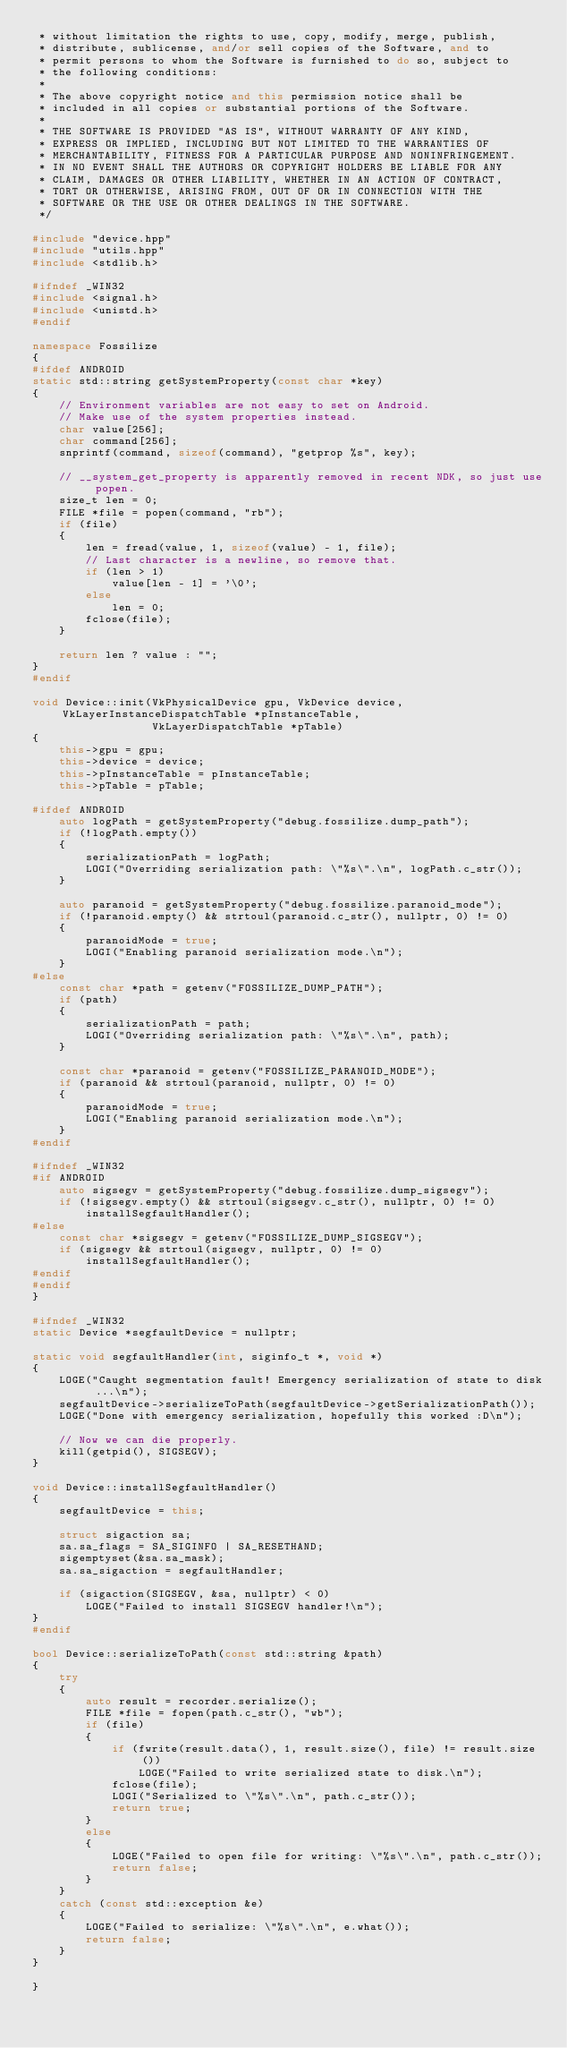Convert code to text. <code><loc_0><loc_0><loc_500><loc_500><_C++_> * without limitation the rights to use, copy, modify, merge, publish,
 * distribute, sublicense, and/or sell copies of the Software, and to
 * permit persons to whom the Software is furnished to do so, subject to
 * the following conditions:
 *
 * The above copyright notice and this permission notice shall be
 * included in all copies or substantial portions of the Software.
 *
 * THE SOFTWARE IS PROVIDED "AS IS", WITHOUT WARRANTY OF ANY KIND,
 * EXPRESS OR IMPLIED, INCLUDING BUT NOT LIMITED TO THE WARRANTIES OF
 * MERCHANTABILITY, FITNESS FOR A PARTICULAR PURPOSE AND NONINFRINGEMENT.
 * IN NO EVENT SHALL THE AUTHORS OR COPYRIGHT HOLDERS BE LIABLE FOR ANY
 * CLAIM, DAMAGES OR OTHER LIABILITY, WHETHER IN AN ACTION OF CONTRACT,
 * TORT OR OTHERWISE, ARISING FROM, OUT OF OR IN CONNECTION WITH THE
 * SOFTWARE OR THE USE OR OTHER DEALINGS IN THE SOFTWARE.
 */

#include "device.hpp"
#include "utils.hpp"
#include <stdlib.h>

#ifndef _WIN32
#include <signal.h>
#include <unistd.h>
#endif

namespace Fossilize
{
#ifdef ANDROID
static std::string getSystemProperty(const char *key)
{
	// Environment variables are not easy to set on Android.
	// Make use of the system properties instead.
	char value[256];
	char command[256];
	snprintf(command, sizeof(command), "getprop %s", key);

	// __system_get_property is apparently removed in recent NDK, so just use popen.
	size_t len = 0;
	FILE *file = popen(command, "rb");
	if (file)
	{
		len = fread(value, 1, sizeof(value) - 1, file);
		// Last character is a newline, so remove that.
		if (len > 1)
			value[len - 1] = '\0';
		else
			len = 0;
		fclose(file);
	}

	return len ? value : "";
}
#endif

void Device::init(VkPhysicalDevice gpu, VkDevice device, VkLayerInstanceDispatchTable *pInstanceTable,
                  VkLayerDispatchTable *pTable)
{
	this->gpu = gpu;
	this->device = device;
	this->pInstanceTable = pInstanceTable;
	this->pTable = pTable;

#ifdef ANDROID
	auto logPath = getSystemProperty("debug.fossilize.dump_path");
	if (!logPath.empty())
	{
		serializationPath = logPath;
		LOGI("Overriding serialization path: \"%s\".\n", logPath.c_str());
	}

	auto paranoid = getSystemProperty("debug.fossilize.paranoid_mode");
	if (!paranoid.empty() && strtoul(paranoid.c_str(), nullptr, 0) != 0)
	{
		paranoidMode = true;
		LOGI("Enabling paranoid serialization mode.\n");
	}
#else
	const char *path = getenv("FOSSILIZE_DUMP_PATH");
	if (path)
	{
		serializationPath = path;
		LOGI("Overriding serialization path: \"%s\".\n", path);
	}

	const char *paranoid = getenv("FOSSILIZE_PARANOID_MODE");
	if (paranoid && strtoul(paranoid, nullptr, 0) != 0)
	{
		paranoidMode = true;
		LOGI("Enabling paranoid serialization mode.\n");
	}
#endif

#ifndef _WIN32
#if ANDROID
	auto sigsegv = getSystemProperty("debug.fossilize.dump_sigsegv");
	if (!sigsegv.empty() && strtoul(sigsegv.c_str(), nullptr, 0) != 0)
		installSegfaultHandler();
#else
	const char *sigsegv = getenv("FOSSILIZE_DUMP_SIGSEGV");
	if (sigsegv && strtoul(sigsegv, nullptr, 0) != 0)
		installSegfaultHandler();
#endif
#endif
}

#ifndef _WIN32
static Device *segfaultDevice = nullptr;

static void segfaultHandler(int, siginfo_t *, void *)
{
	LOGE("Caught segmentation fault! Emergency serialization of state to disk ...\n");
	segfaultDevice->serializeToPath(segfaultDevice->getSerializationPath());
	LOGE("Done with emergency serialization, hopefully this worked :D\n");

	// Now we can die properly.
	kill(getpid(), SIGSEGV);
}

void Device::installSegfaultHandler()
{
	segfaultDevice = this;

	struct sigaction sa;
	sa.sa_flags = SA_SIGINFO | SA_RESETHAND;
	sigemptyset(&sa.sa_mask);
	sa.sa_sigaction = segfaultHandler;

	if (sigaction(SIGSEGV, &sa, nullptr) < 0)
		LOGE("Failed to install SIGSEGV handler!\n");
}
#endif

bool Device::serializeToPath(const std::string &path)
{
	try
	{
		auto result = recorder.serialize();
		FILE *file = fopen(path.c_str(), "wb");
		if (file)
		{
			if (fwrite(result.data(), 1, result.size(), file) != result.size())
				LOGE("Failed to write serialized state to disk.\n");
			fclose(file);
			LOGI("Serialized to \"%s\".\n", path.c_str());
			return true;
		}
		else
		{
			LOGE("Failed to open file for writing: \"%s\".\n", path.c_str());
			return false;
		}
	}
	catch (const std::exception &e)
	{
		LOGE("Failed to serialize: \"%s\".\n", e.what());
		return false;
	}
}

}</code> 